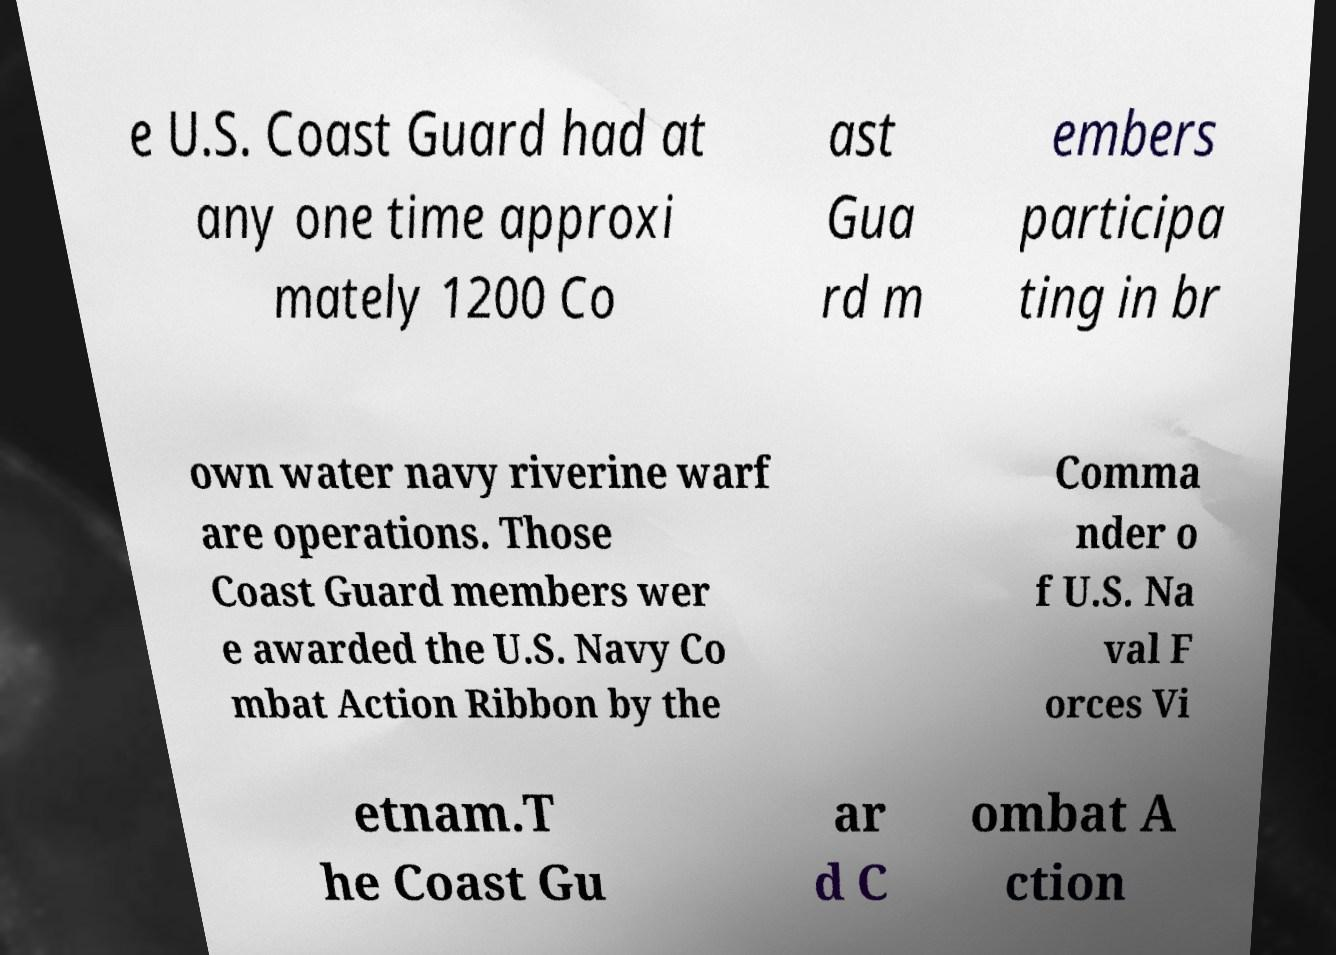I need the written content from this picture converted into text. Can you do that? e U.S. Coast Guard had at any one time approxi mately 1200 Co ast Gua rd m embers participa ting in br own water navy riverine warf are operations. Those Coast Guard members wer e awarded the U.S. Navy Co mbat Action Ribbon by the Comma nder o f U.S. Na val F orces Vi etnam.T he Coast Gu ar d C ombat A ction 